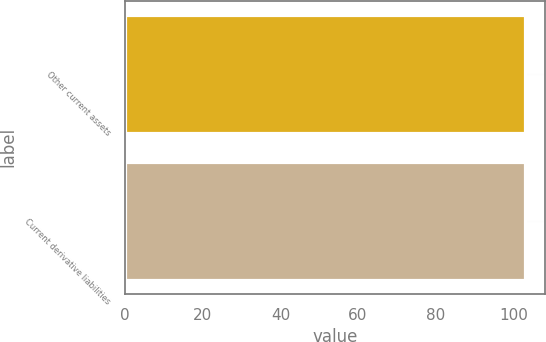Convert chart. <chart><loc_0><loc_0><loc_500><loc_500><bar_chart><fcel>Other current assets<fcel>Current derivative liabilities<nl><fcel>103<fcel>103.1<nl></chart> 